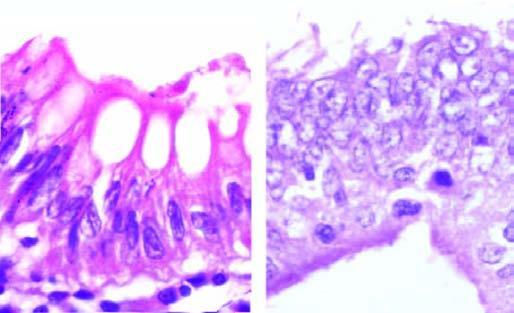how is microscopic appearance of loss of nuclear polarity contrasted?
Answer the question using a single word or phrase. With normal basal polarity in columnar epithelium 